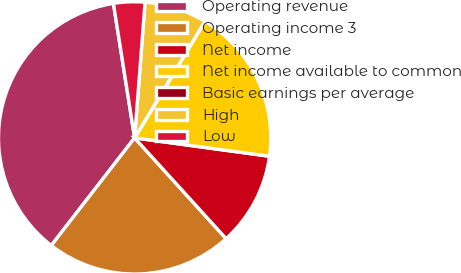Convert chart to OTSL. <chart><loc_0><loc_0><loc_500><loc_500><pie_chart><fcel>Operating revenue<fcel>Operating income 3<fcel>Net income<fcel>Net income available to common<fcel>Basic earnings per average<fcel>High<fcel>Low<nl><fcel>37.02%<fcel>22.22%<fcel>11.11%<fcel>18.51%<fcel>0.01%<fcel>7.41%<fcel>3.71%<nl></chart> 